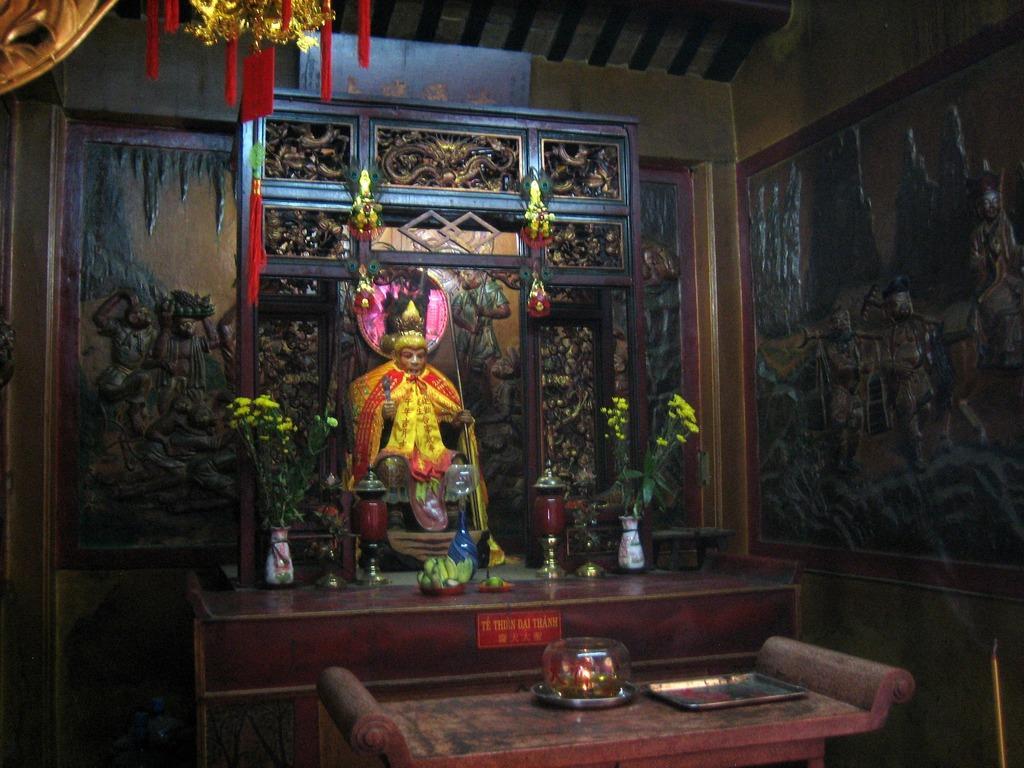How would you summarize this image in a sentence or two? In this image there are two tables, on one table there is a tray and a bowl, on another table there are flowers pots and other objects, in the background there are sculptures, at the top there is a ceiling and few objects hanged for that ceiling. 